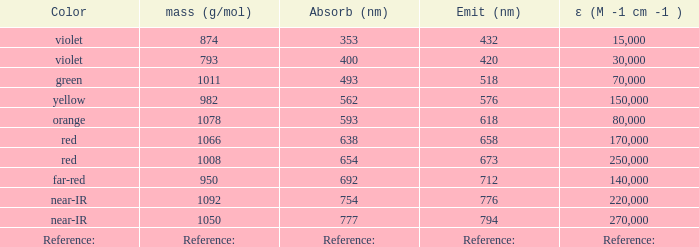Which Emission (in nanometers) has an absorbtion of 593 nm? 618.0. 